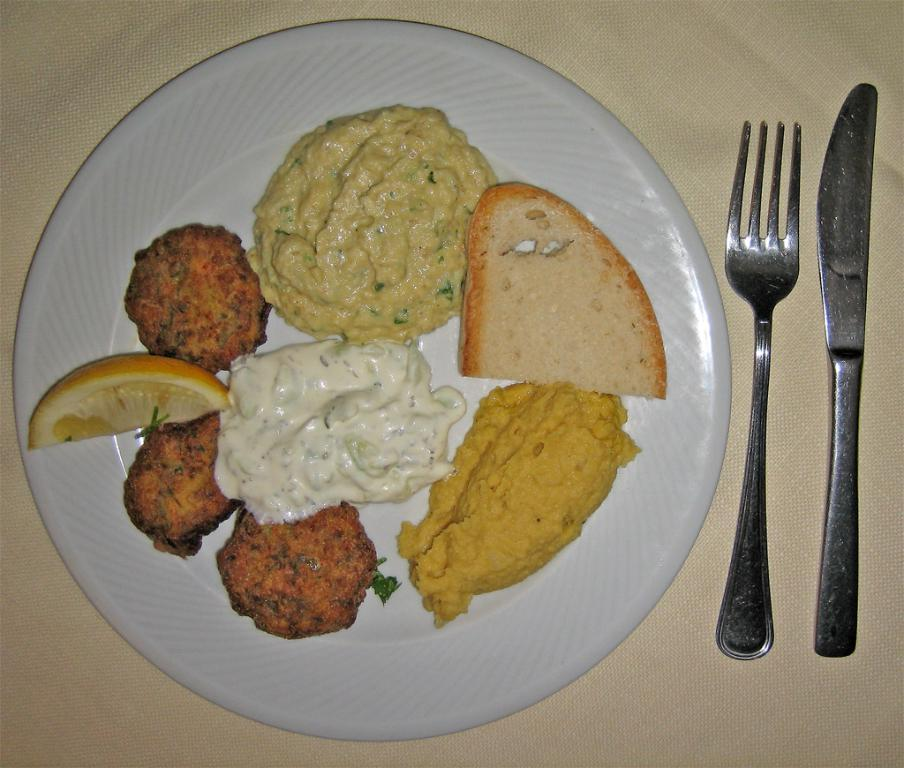What utensils are visible in the image? There is a fork and a knife in the image. What is the plate used for in the image? The plate is used to hold food items in the image. What type of material is the cloth made of? The cloth is present in the image, but the material is not specified. How many bikes are parked on the sheet in the image? There are no bikes or sheets present in the image. What advice is given on the plate in the image? There is no advice present on the plate in the image. 